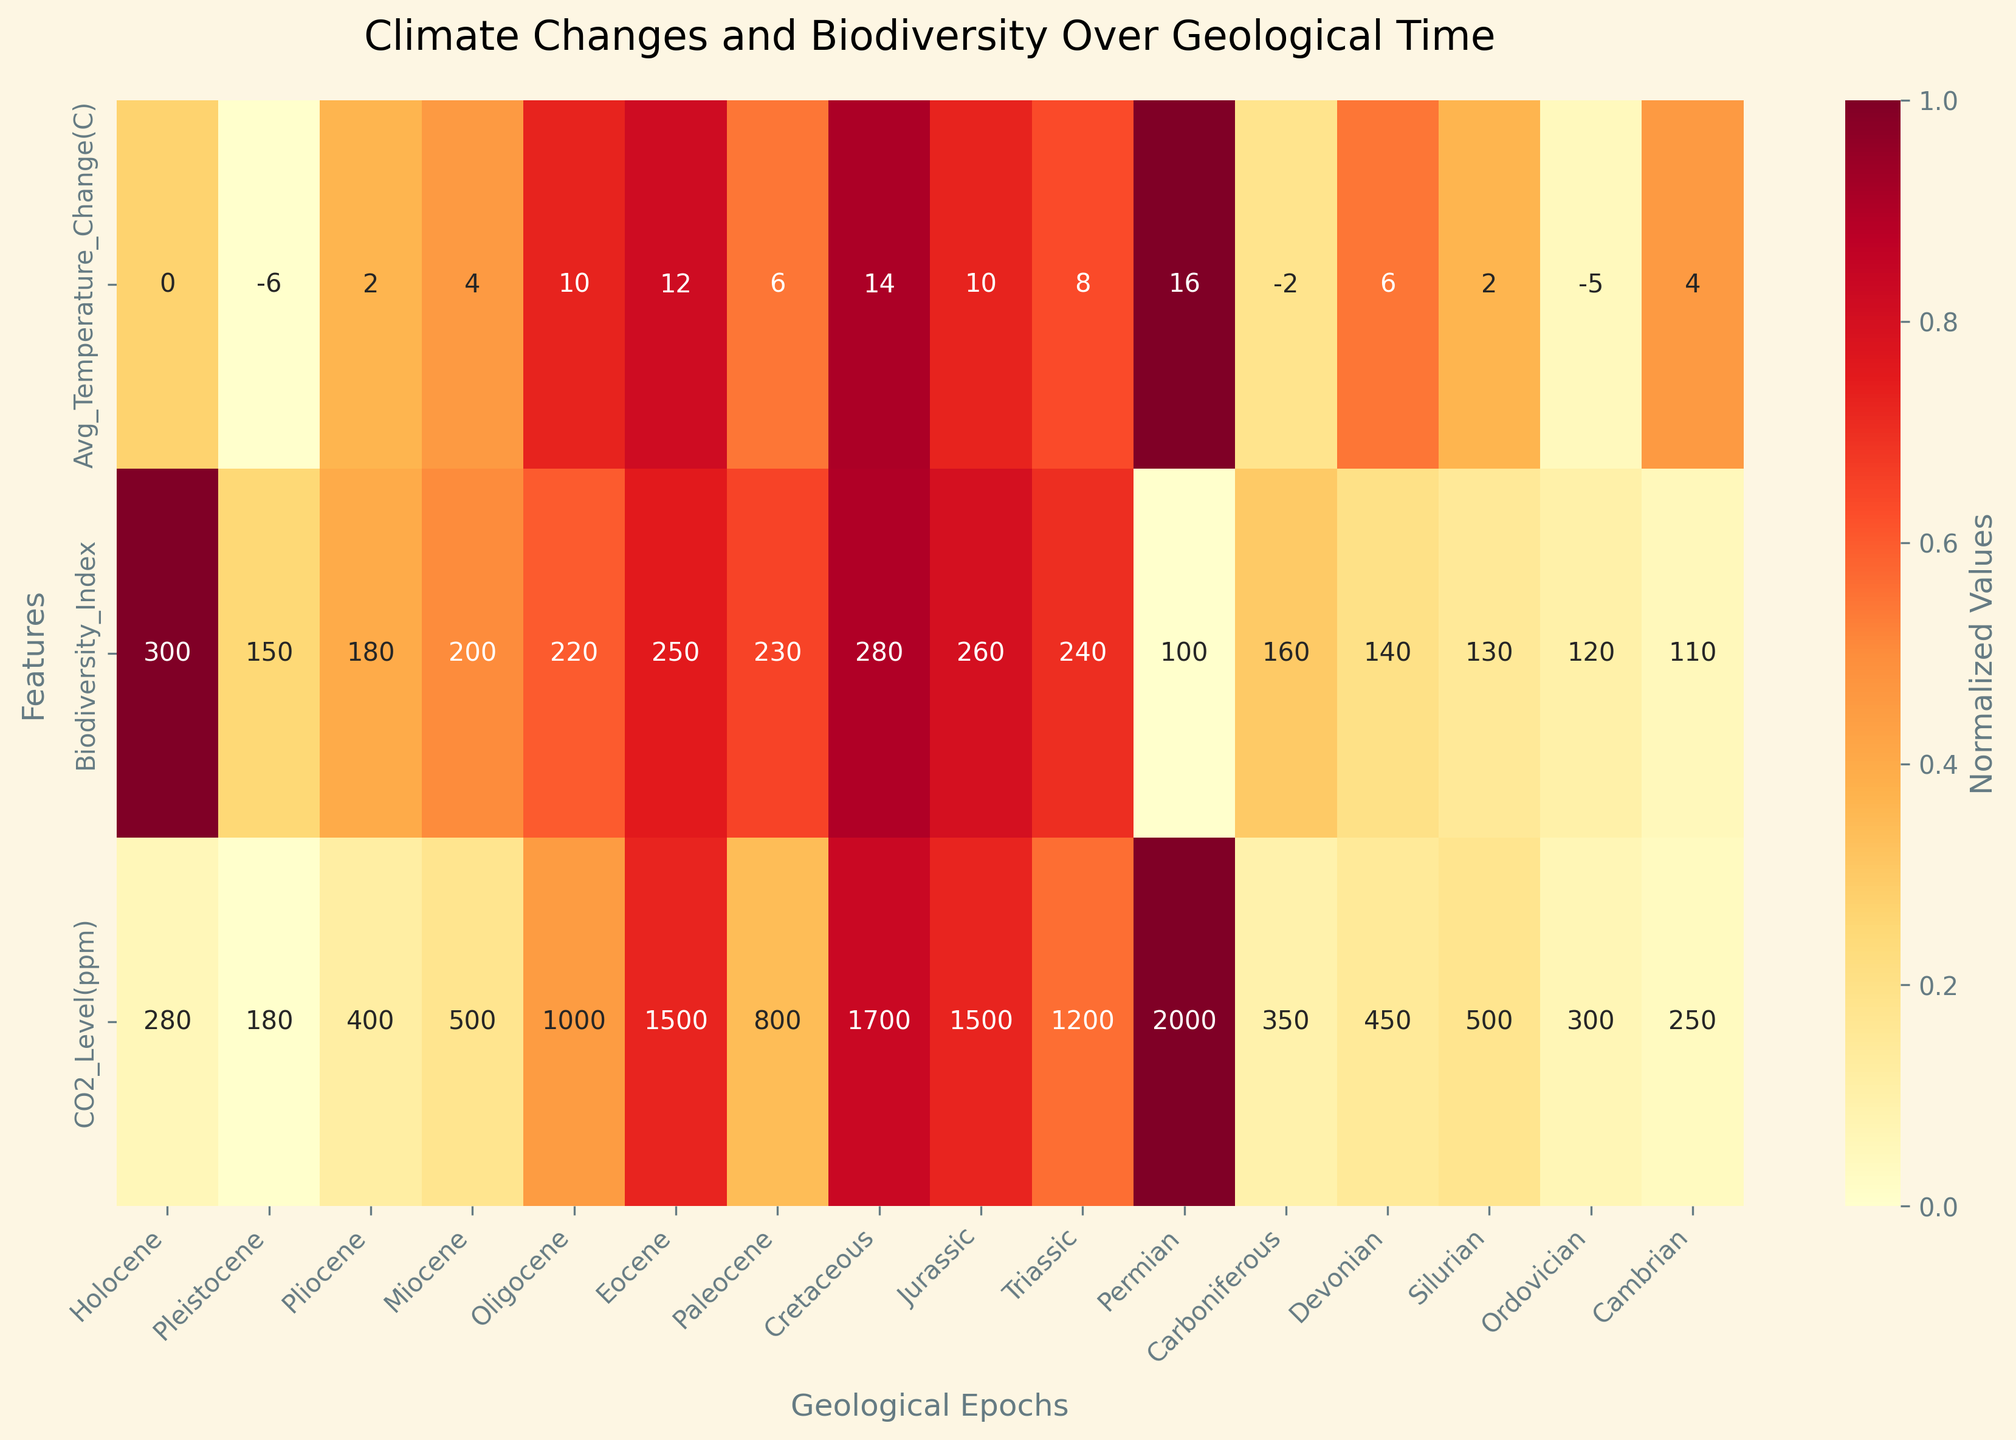What's the title of the heatmap? The title of the heatmap is typically placed at the top center of the plot and often gives a summary of the data presented. In this case, the title is "Climate Changes and Biodiversity Over Geological Time".
Answer: Climate Changes and Biodiversity Over Geological Time Which epoch has the highest biodiversity index? To find the epoch with the highest biodiversity index, look at the row labeled "Biodiversity_Index" and identify the epoch with the highest annotated value. The highest value in this row is 300, corresponding to the Holocene epoch.
Answer: Holocene Which periods show an average temperature change of 10°C? Check the row labeled "Avg_Temperature_Change(C)" and look for values that are annotated as 10.0°C. The periods with an average temperature change of 10°C are the Oligocene and Jurassic periods.
Answer: Oligocene, Jurassic How does the CO2 level during the Cretaceous compare to that of the Permian? To compare the CO2 levels, observe the row "CO2_Level(ppm)". The CO2 levels for the Cretaceous (1700 ppm) and the Permian (2000 ppm) can be identified, and it's evident that the CO2 level during the Permian is higher than during the Cretaceous.
Answer: Permian has a higher CO2 level than Cretaceous Which geological period experienced the highest average temperature change? Look at the "Avg_Temperature_Change(C)" row and identify the highest number. The highest average temperature change recorded is 16.0°C, which occurs in the Permian period.
Answer: Permian Is there an epoch with a negative average temperature change, and if so, which ones? Check the "Avg_Temperature_Change(C)" row for negative values. The epochs with negative average temperature changes are the Pleistocene (-6.0°C), Carboniferous (-2.0°C), and Ordovician (-5.0°C).
Answer: Pleistocene, Carboniferous, Ordovician What is the discrepancy in biodiversity index between the Holocene and the Pleistocene epochs? To find the discrepancy, subtract the biodiversity index of the Pleistocene (150) from that of the Holocene (300). The difference is 300 - 150 = 150.
Answer: 150 During which period was the biodiversity index the lowest, and what was the corresponding CO2 level? Identify the lowest value in the "Biodiversity_Index" row, which is 100, occurring in the Permian period. The corresponding CO2 level for the Permian is 2000 ppm.
Answer: Permian; 2000 ppm Was there any period where the average temperature change was exactly 0°C? Check the "Avg_Temperature_Change(C)" row for a value of 0.0°C. The only period with this value is the Holocene epoch.
Answer: Holocene What are the normalized CO2 levels for the Cretaceous and Jurassic periods, and how do they compare? In a heatmap, normalized values are shown using colors. Identify the columns for Cretaceous and Jurassic in the "CO2_Level(ppm)" row to compare their shades of color. The Cretaceous CO2 level (normalized value) is higher than the Jurassic (1700 ppm and 1500 ppm respectively).
Answer: Cretaceous has a higher normalized CO2 level than Jurassic 